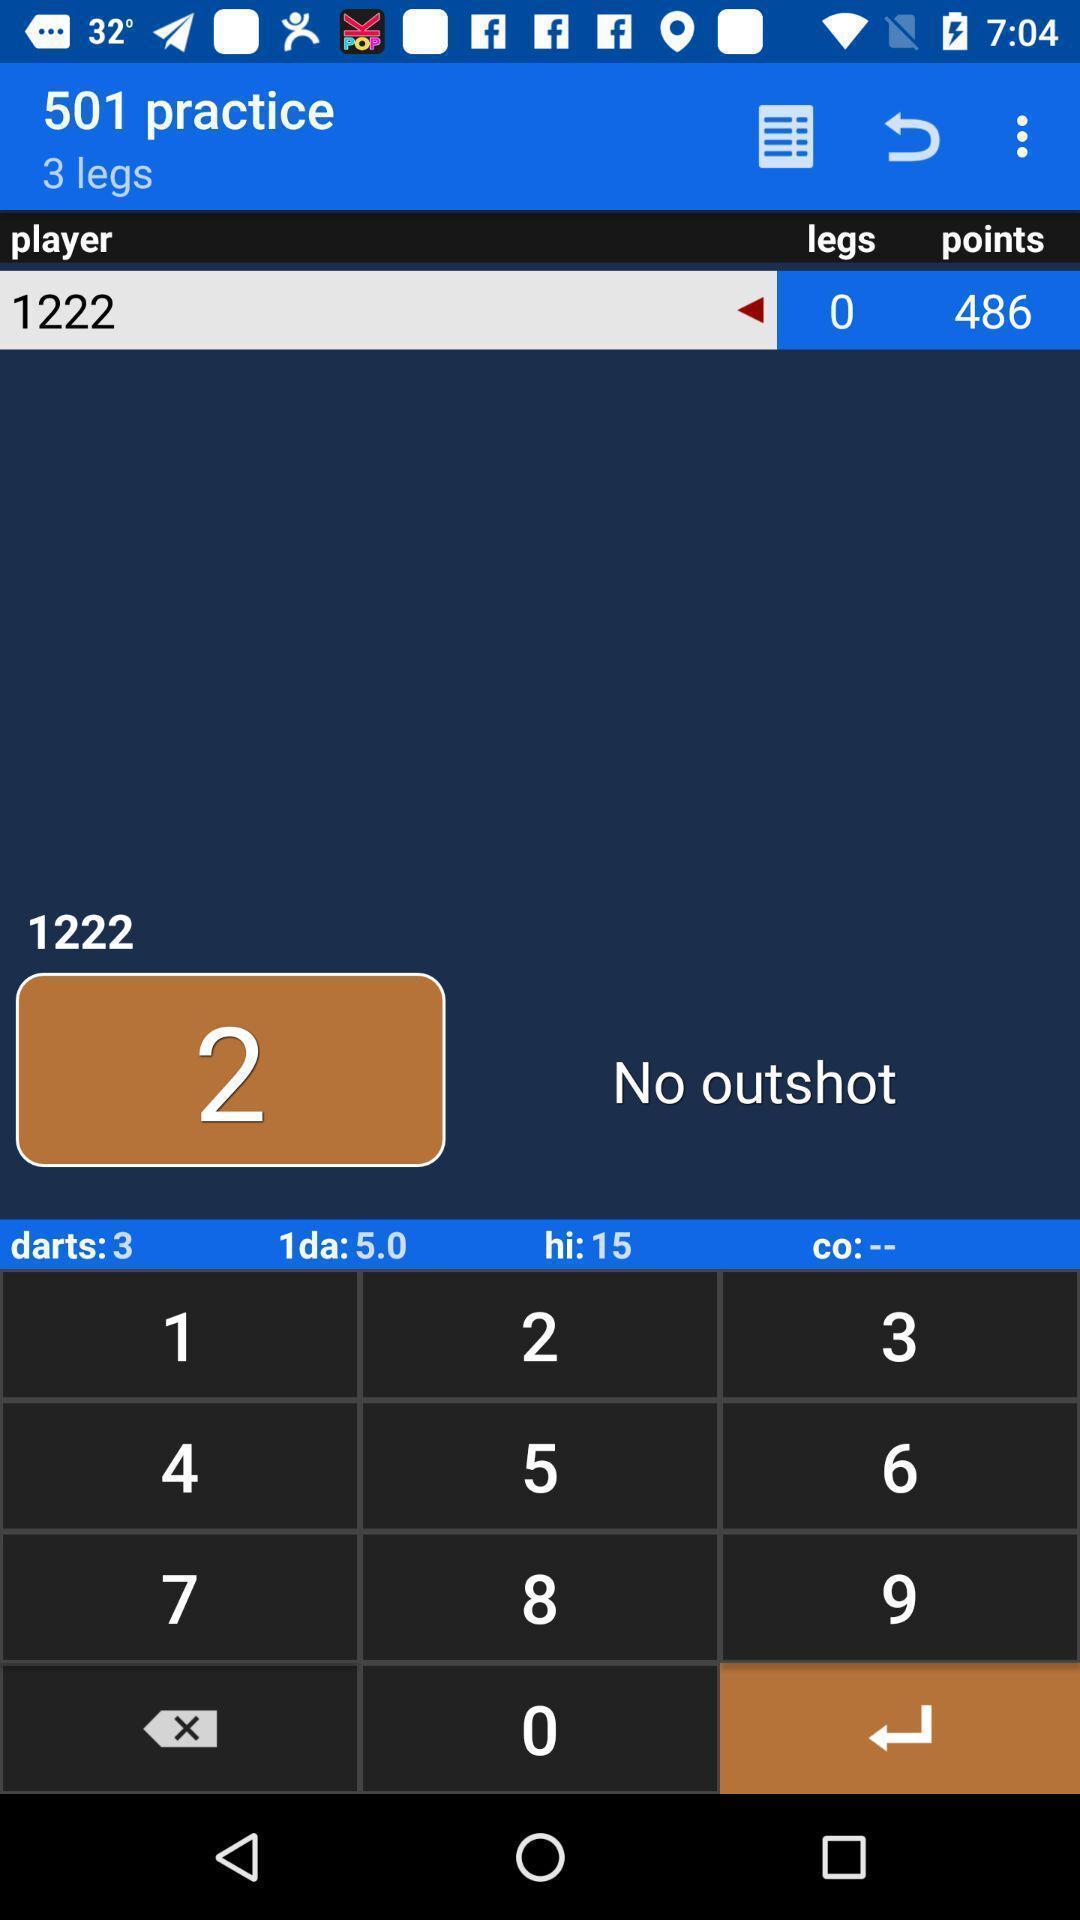Describe the visual elements of this screenshot. Page showing scoreboard. 